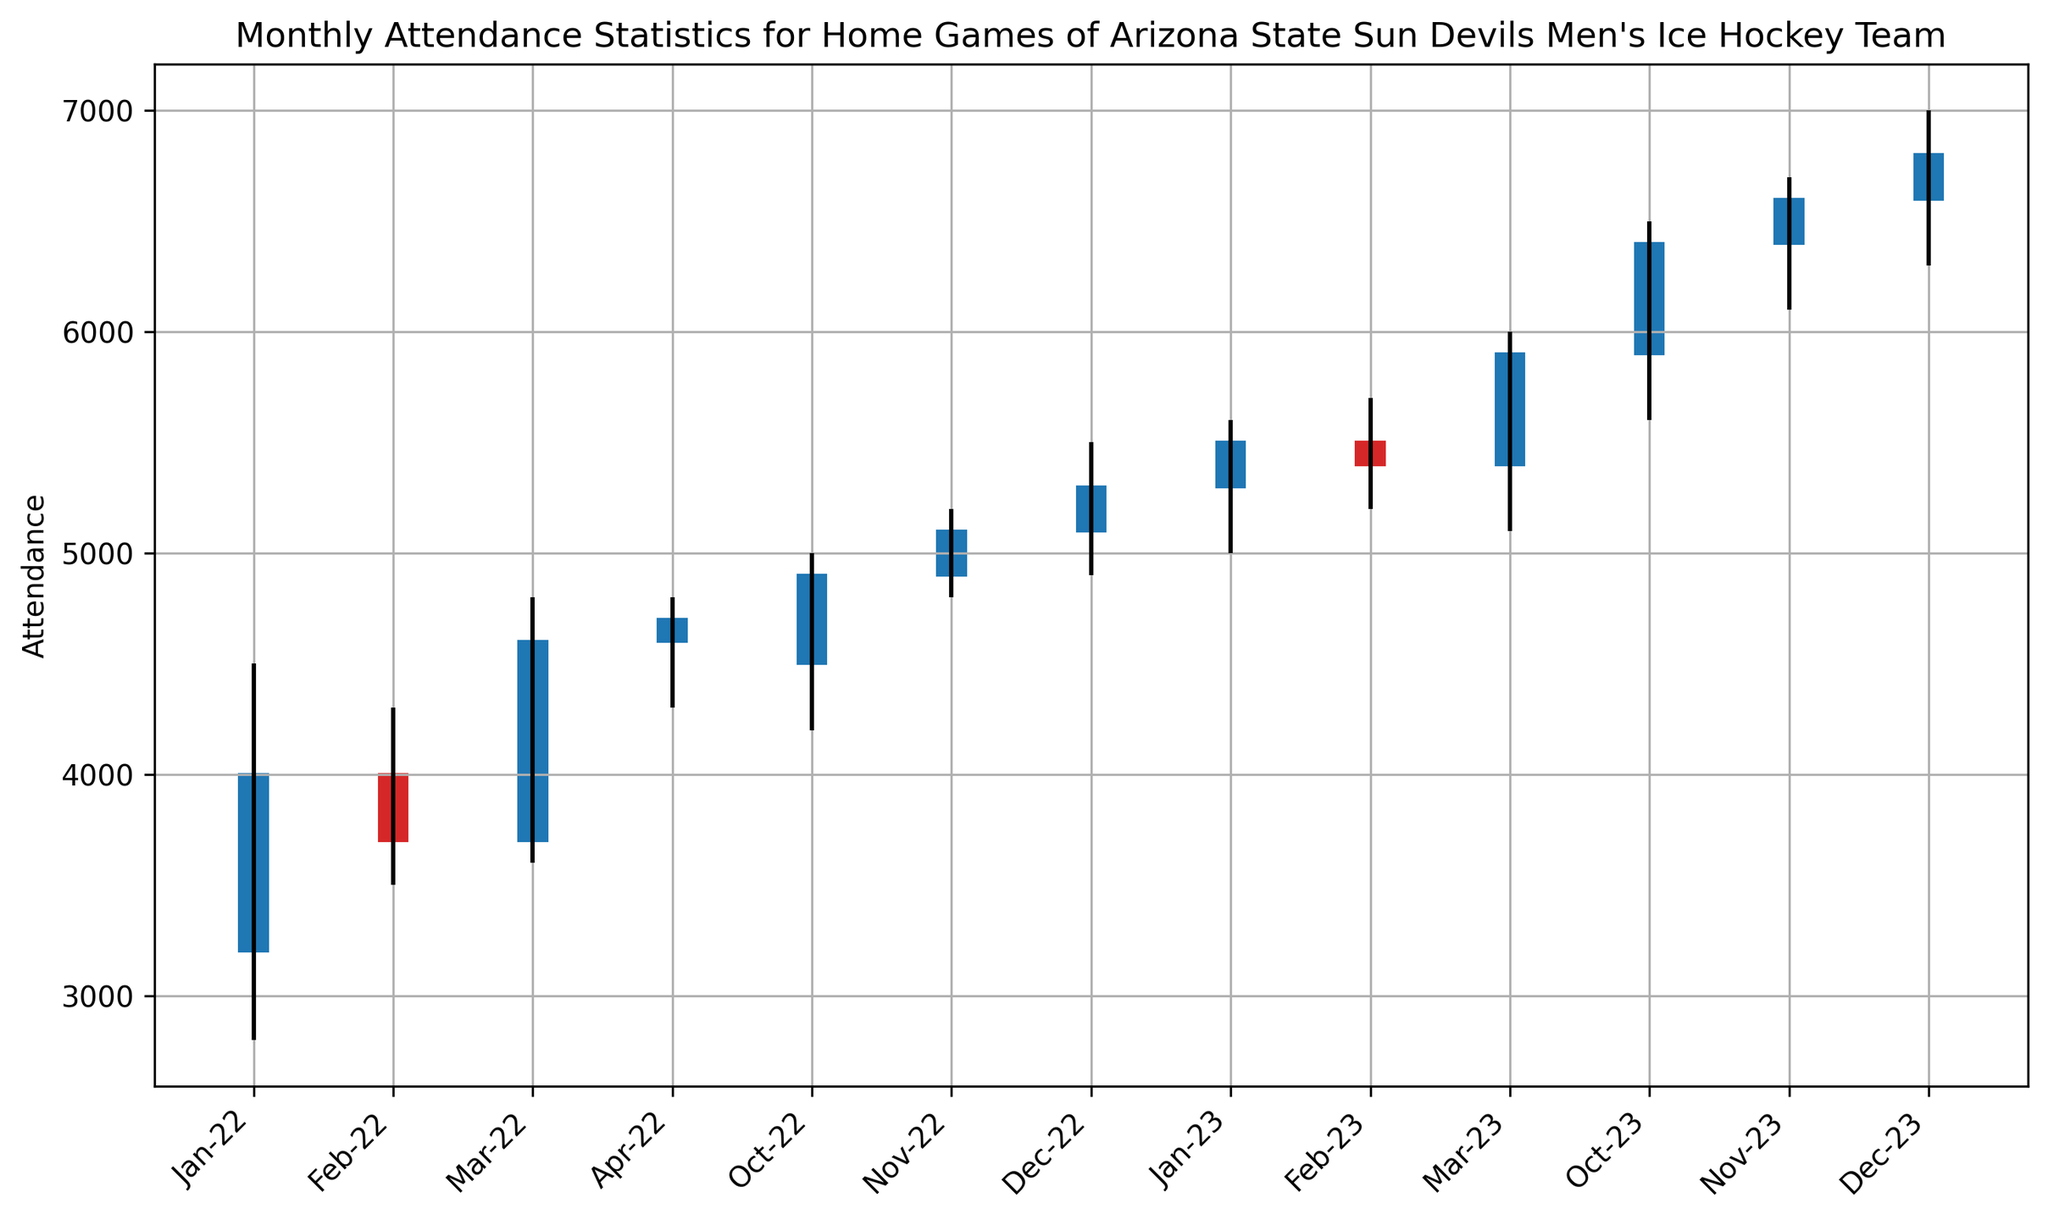Which month had the highest closing attendance? The highest closing attendance can be identified by looking at the topmost end of the rectangles (or candlesticks) in the figure. The month with the highest rectangle top end represents the highest closing attendance.
Answer: Dec-23 What's the difference between the high and low attendance in Nov-23? To find the difference between high and low attendance for Nov-23, look at the positions of the highest and lowest vertical point of the candlestick for Nov-23. Subtract the low attendance value from the high attendance value.
Answer: 6700 - 6100 = 600 Did monthly attendance statistics show a consistent upward trend in the fall months of 2023 (Oct, Nov, Dec)? Check if each subsequent month has a higher closing attendance compared to the previous month from Oct-23 to Dec-23. If each month shows an increase in the closing attendance, then the trend is upward.
Answer: Yes Which month showed the largest increase in attendance when comparing the opening and closing values? The largest increase in attendance can be found by calculating the difference between the close and open values for each month and identifying the month with the highest difference.  Compare all months to find the maximum difference.
Answer: Mar-23 Which month had the smallest range of attendance (difference between high and low)? To identify the month with the smallest range, calculate the difference between the high and low attendance values for each month. Compare these values and find the month with the smallest difference.
Answer: Feb-23 Was there any month where the attendance decreased from the open to close? To check if there was any month where attendance decreased from open to close, look for any month where the bottom of the rectangle is at a higher position than the top of the rectangle, indicating a closing lower than the opening.
Answer: Feb-22 What is the average closing attendance for 2022? Add up the closing attendance values for each month in 2022 and divide by the number of months to get the average closing attendance.
Answer: (4000 + 3700 + 4600 + 4700 + 4900 + 5100 + 5300) / 7 = 4614 What was the range of attendance in March 2022, and how does it compare to March 2023? Calculate the range of attendance for both March 2022 and March 2023 by subtracting the low value from the high value for each month. Compare the two ranges to determine the difference.
Answer: Mar-22: 4800 - 3600 = 1200, Mar-23: 6000 - 5100 = 900, March 2022 had a higher range 